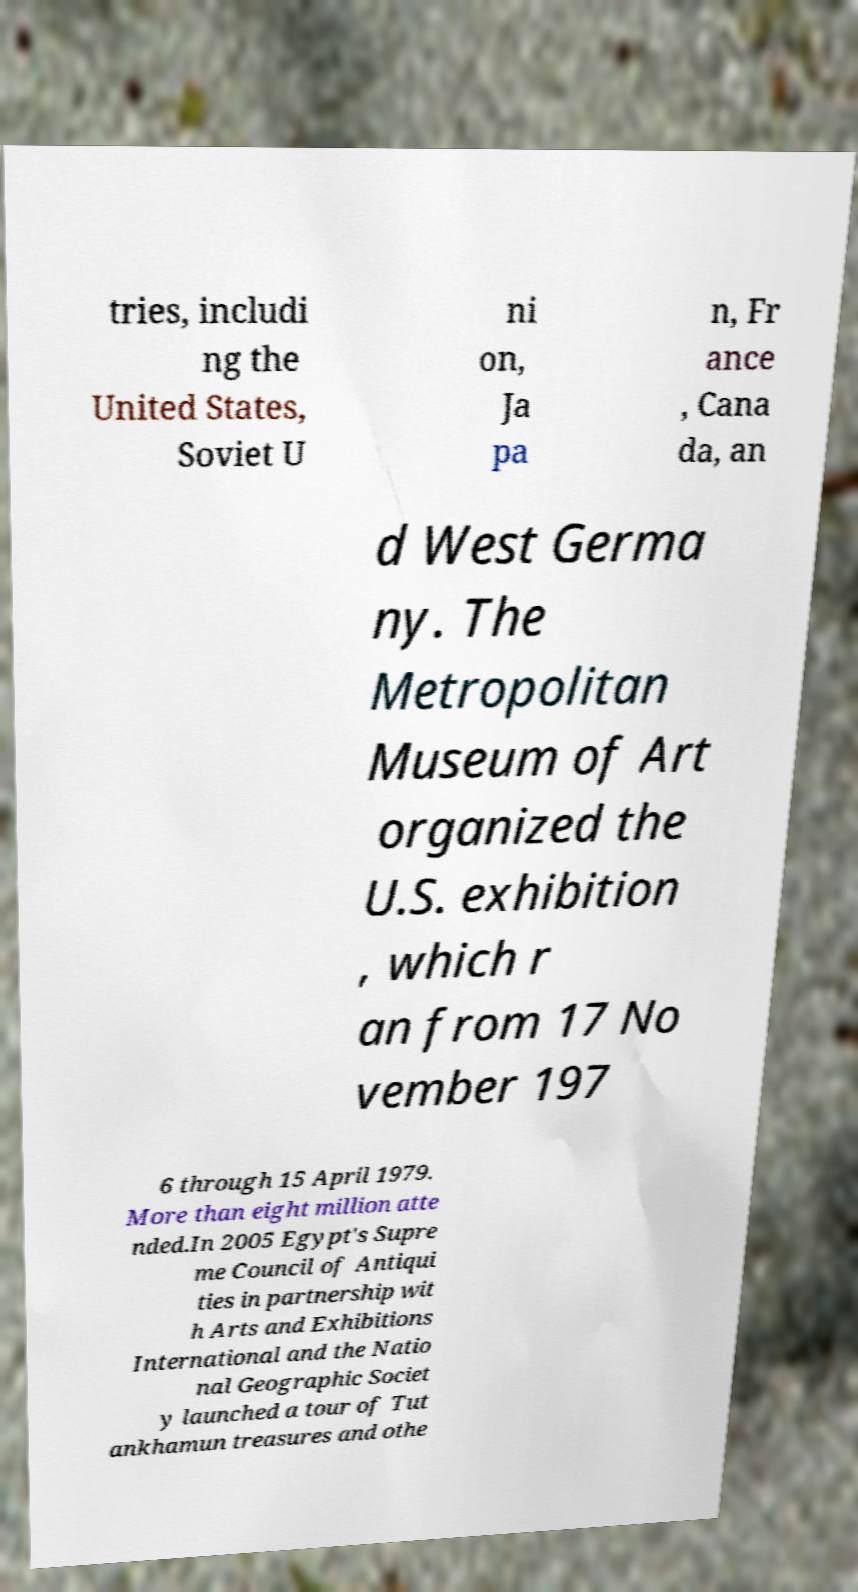Please identify and transcribe the text found in this image. tries, includi ng the United States, Soviet U ni on, Ja pa n, Fr ance , Cana da, an d West Germa ny. The Metropolitan Museum of Art organized the U.S. exhibition , which r an from 17 No vember 197 6 through 15 April 1979. More than eight million atte nded.In 2005 Egypt's Supre me Council of Antiqui ties in partnership wit h Arts and Exhibitions International and the Natio nal Geographic Societ y launched a tour of Tut ankhamun treasures and othe 